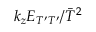Convert formula to latex. <formula><loc_0><loc_0><loc_500><loc_500>k _ { z } E _ { T ^ { \prime } T ^ { \prime } } / \bar { T } ^ { 2 }</formula> 